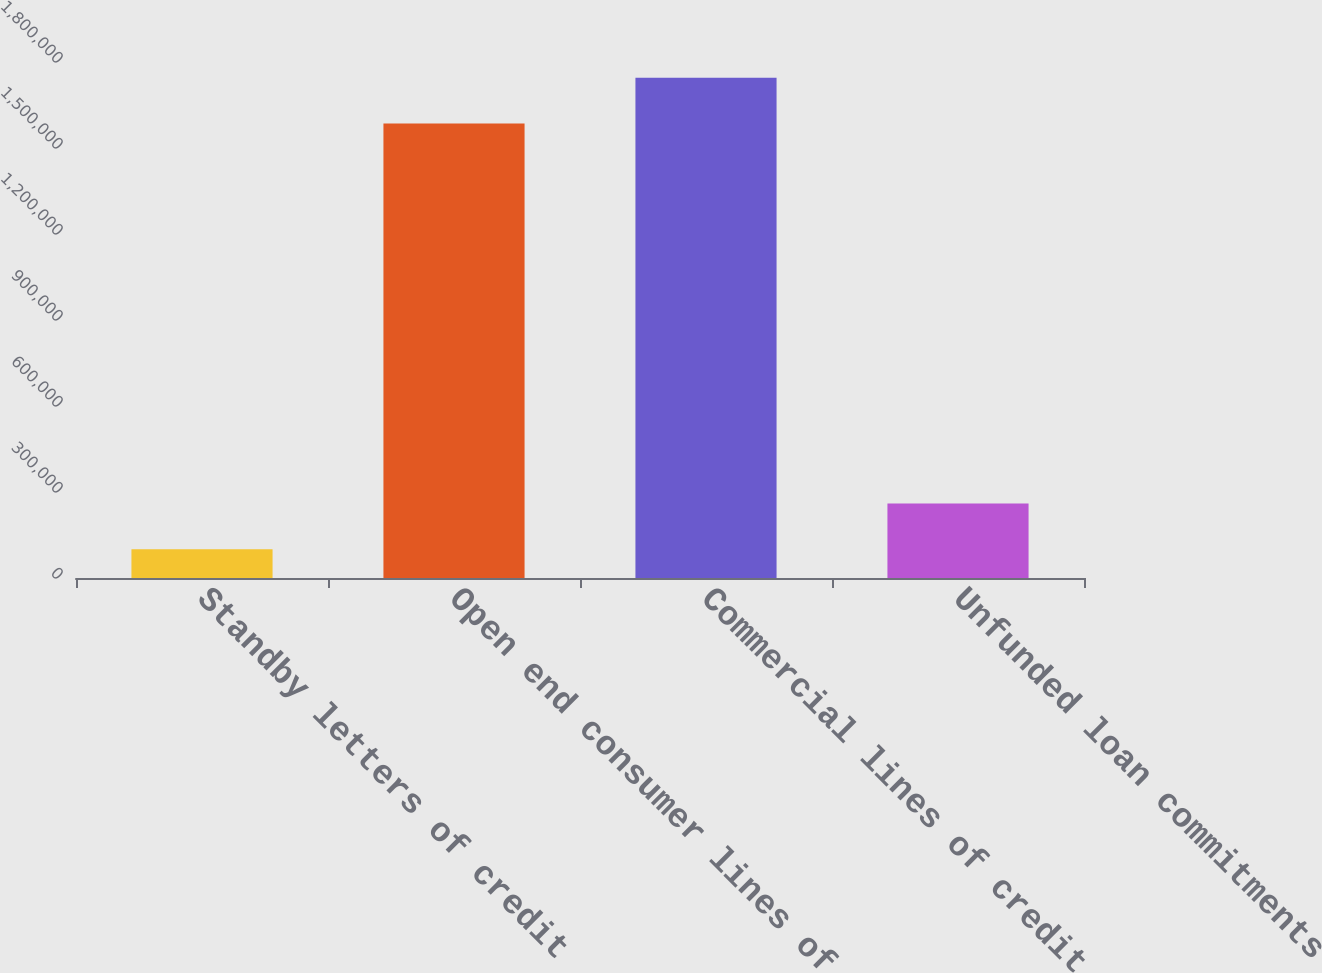Convert chart. <chart><loc_0><loc_0><loc_500><loc_500><bar_chart><fcel>Standby letters of credit<fcel>Open end consumer lines of<fcel>Commercial lines of credit<fcel>Unfunded loan commitments<nl><fcel>100582<fcel>1.58572e+06<fcel>1.74495e+06<fcel>259813<nl></chart> 